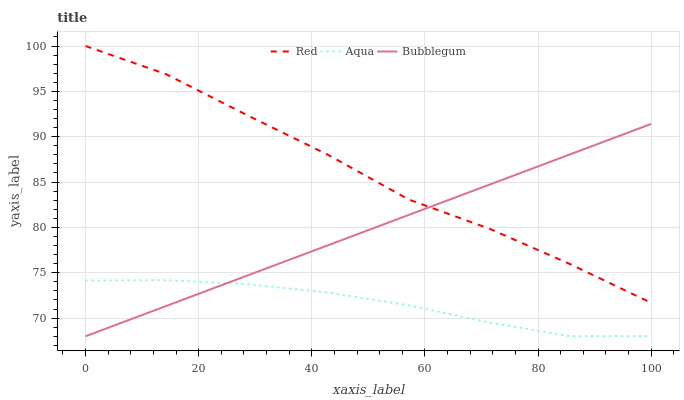Does Aqua have the minimum area under the curve?
Answer yes or no. Yes. Does Red have the maximum area under the curve?
Answer yes or no. Yes. Does Bubblegum have the minimum area under the curve?
Answer yes or no. No. Does Bubblegum have the maximum area under the curve?
Answer yes or no. No. Is Bubblegum the smoothest?
Answer yes or no. Yes. Is Red the roughest?
Answer yes or no. Yes. Is Red the smoothest?
Answer yes or no. No. Is Bubblegum the roughest?
Answer yes or no. No. Does Aqua have the lowest value?
Answer yes or no. Yes. Does Red have the lowest value?
Answer yes or no. No. Does Red have the highest value?
Answer yes or no. Yes. Does Bubblegum have the highest value?
Answer yes or no. No. Is Aqua less than Red?
Answer yes or no. Yes. Is Red greater than Aqua?
Answer yes or no. Yes. Does Bubblegum intersect Red?
Answer yes or no. Yes. Is Bubblegum less than Red?
Answer yes or no. No. Is Bubblegum greater than Red?
Answer yes or no. No. Does Aqua intersect Red?
Answer yes or no. No. 